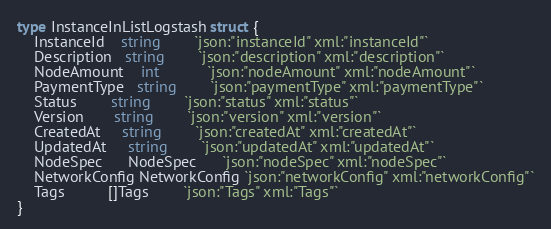Convert code to text. <code><loc_0><loc_0><loc_500><loc_500><_Go_>type InstanceInListLogstash struct {
	InstanceId    string        `json:"instanceId" xml:"instanceId"`
	Description   string        `json:"description" xml:"description"`
	NodeAmount    int           `json:"nodeAmount" xml:"nodeAmount"`
	PaymentType   string        `json:"paymentType" xml:"paymentType"`
	Status        string        `json:"status" xml:"status"`
	Version       string        `json:"version" xml:"version"`
	CreatedAt     string        `json:"createdAt" xml:"createdAt"`
	UpdatedAt     string        `json:"updatedAt" xml:"updatedAt"`
	NodeSpec      NodeSpec      `json:"nodeSpec" xml:"nodeSpec"`
	NetworkConfig NetworkConfig `json:"networkConfig" xml:"networkConfig"`
	Tags          []Tags        `json:"Tags" xml:"Tags"`
}
</code> 